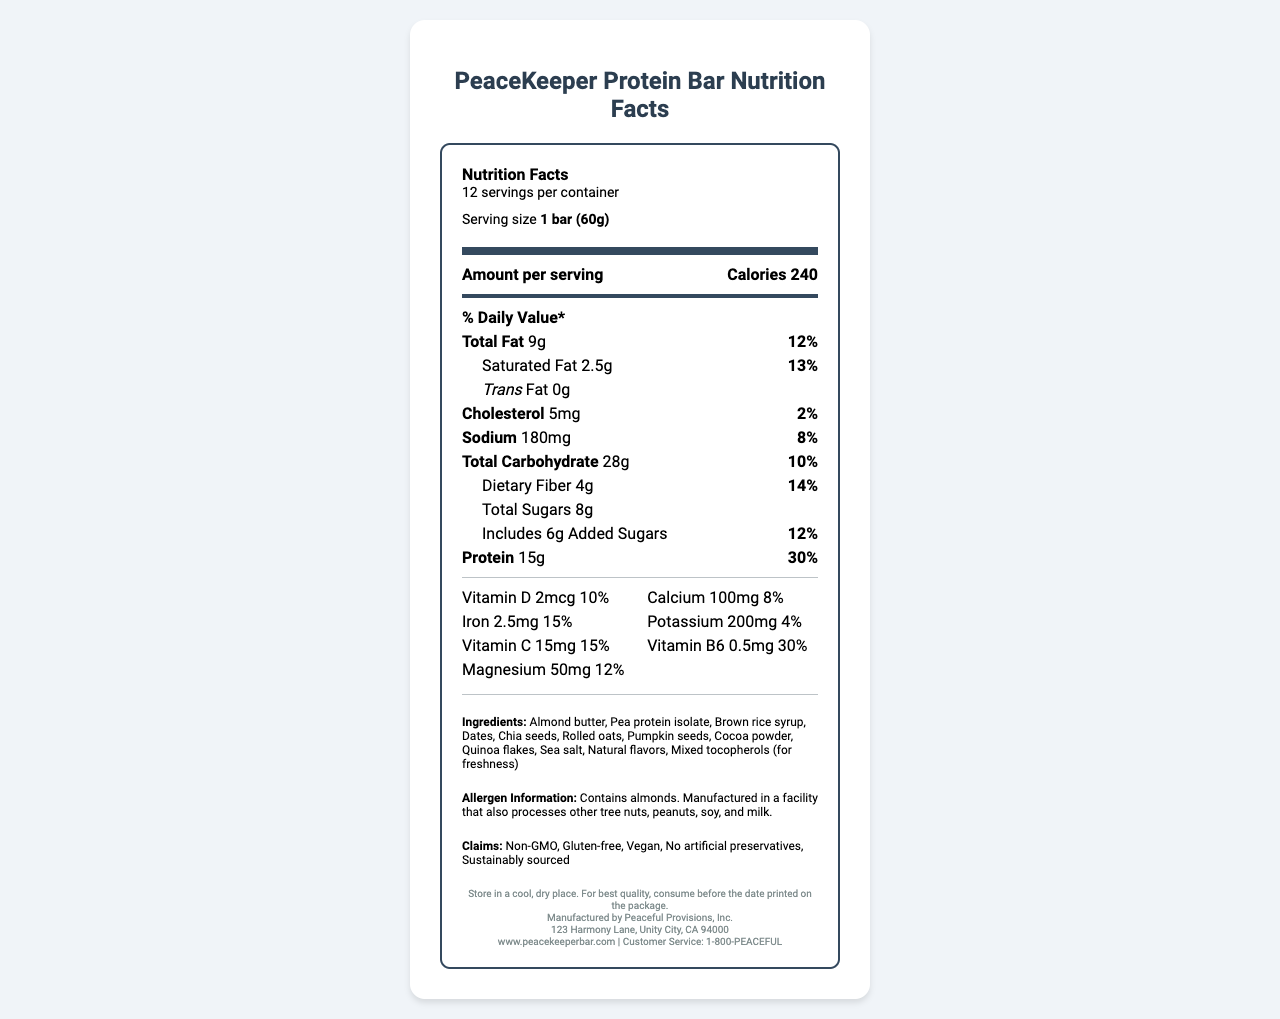What is the serving size of the PeaceKeeper Protein Bar? The document specifies that the serving size of the protein bar is 1 bar, which weighs 60 grams.
Answer: 1 bar (60g) How many calories are there per serving? According to the document, each serving contains 240 calories.
Answer: 240 What is the total amount of fat per serving, and what percentage of the daily value does it represent? The document shows that the total fat content per serving is 9 grams, which represents 12% of the daily value.
Answer: 9g, 12% How much protein is in one serving of this protein bar? The document states that there are 15 grams of protein in one serving.
Answer: 15g What are the main allergens in this protein bar? The allergen information section in the document notes that the bar contains almonds.
Answer: Almonds Which two minerals are present at 15% of the daily value? A. Iron and Potassium B. Calcium and Vitamin C C. Iron and Vitamin C D. Magnesium and Vitamin D The document shows that Iron is at 15% of the daily value (2.5mg), and Vitamin C is also at 15% of the daily value (15mg).
Answer: C. Iron and Vitamin C Which claim is NOT true about the PeaceKeeper Protein Bar? A. Non-GMO B. Gluten-free C. Contains artificial preservatives D. Vegan The claims section states that the bar has no artificial preservatives, making the correct option C.
Answer: C. Contains artificial preservatives Does the protein bar contain any trans fat? The document indicates that the trans fat content is 0 grams.
Answer: No Summarize the main nutritional features and claims of the PeaceKeeper Protein Bar. The protein bar is positioned as a healthy, on-the-go sustenance option, with an emphasis on high protein and essential vitamins and minerals, while avoiding artificial additives.
Answer: The PeaceKeeper Protein Bar offers 240 calories per serving, with significant protein (15g, 30% DV), moderate fats (9g total fat, 12% DV), and beneficial vitamins and minerals like Vitamin D, Iron, and Vitamin C. It claims to be non-GMO, gluten-free, vegan, and made with no artificial preservatives. How many servings are there per container of the PeaceKeeper Protein Bar? The document specifies that there are 12 servings per container.
Answer: 12 What is the amount of added sugars per serving, and what percentage of the daily value does this represent? The document lists 6 grams of added sugars per serving, which corresponds to 12% of the daily value.
Answer: 6g, 12% What types of natural flavors are included in the ingredients? The document lists "Natural flavors" as an ingredient but does not specify which types.
Answer: Cannot be determined From which address is the PeaceKeeper Protein Bar manufactured? The manufacturer's address is displayed in the footer section of the document.
Answer: 123 Harmony Lane, Unity City, CA 94000 